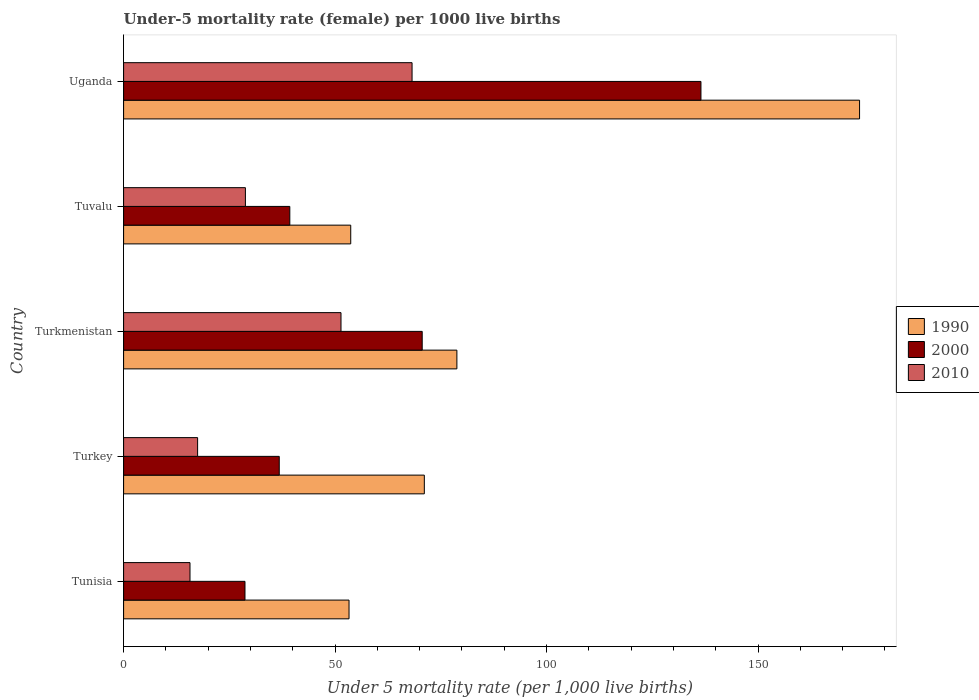How many groups of bars are there?
Ensure brevity in your answer.  5. What is the label of the 1st group of bars from the top?
Provide a succinct answer. Uganda. In how many cases, is the number of bars for a given country not equal to the number of legend labels?
Ensure brevity in your answer.  0. What is the under-five mortality rate in 2000 in Turkey?
Give a very brief answer. 36.8. Across all countries, what is the maximum under-five mortality rate in 2010?
Give a very brief answer. 68.2. Across all countries, what is the minimum under-five mortality rate in 2000?
Ensure brevity in your answer.  28.7. In which country was the under-five mortality rate in 1990 maximum?
Your answer should be very brief. Uganda. In which country was the under-five mortality rate in 2000 minimum?
Keep it short and to the point. Tunisia. What is the total under-five mortality rate in 1990 in the graph?
Provide a short and direct response. 430.9. What is the difference between the under-five mortality rate in 2010 in Tunisia and that in Turkmenistan?
Give a very brief answer. -35.7. What is the difference between the under-five mortality rate in 2010 in Uganda and the under-five mortality rate in 1990 in Tunisia?
Keep it short and to the point. 14.9. What is the average under-five mortality rate in 2010 per country?
Keep it short and to the point. 36.32. What is the difference between the under-five mortality rate in 2010 and under-five mortality rate in 1990 in Turkmenistan?
Offer a terse response. -27.4. What is the ratio of the under-five mortality rate in 2000 in Tunisia to that in Turkmenistan?
Your answer should be compact. 0.41. Is the difference between the under-five mortality rate in 2010 in Turkmenistan and Uganda greater than the difference between the under-five mortality rate in 1990 in Turkmenistan and Uganda?
Offer a very short reply. Yes. What is the difference between the highest and the second highest under-five mortality rate in 2000?
Give a very brief answer. 65.9. What is the difference between the highest and the lowest under-five mortality rate in 2010?
Make the answer very short. 52.5. In how many countries, is the under-five mortality rate in 1990 greater than the average under-five mortality rate in 1990 taken over all countries?
Your response must be concise. 1. What does the 1st bar from the top in Turkey represents?
Keep it short and to the point. 2010. Is it the case that in every country, the sum of the under-five mortality rate in 2010 and under-five mortality rate in 1990 is greater than the under-five mortality rate in 2000?
Your answer should be very brief. Yes. Are all the bars in the graph horizontal?
Provide a short and direct response. Yes. How many countries are there in the graph?
Your answer should be compact. 5. What is the difference between two consecutive major ticks on the X-axis?
Offer a very short reply. 50. Does the graph contain any zero values?
Your answer should be very brief. No. Where does the legend appear in the graph?
Your response must be concise. Center right. How many legend labels are there?
Ensure brevity in your answer.  3. What is the title of the graph?
Your answer should be compact. Under-5 mortality rate (female) per 1000 live births. Does "2002" appear as one of the legend labels in the graph?
Make the answer very short. No. What is the label or title of the X-axis?
Provide a succinct answer. Under 5 mortality rate (per 1,0 live births). What is the label or title of the Y-axis?
Provide a succinct answer. Country. What is the Under 5 mortality rate (per 1,000 live births) in 1990 in Tunisia?
Your answer should be compact. 53.3. What is the Under 5 mortality rate (per 1,000 live births) of 2000 in Tunisia?
Provide a short and direct response. 28.7. What is the Under 5 mortality rate (per 1,000 live births) in 2010 in Tunisia?
Your answer should be compact. 15.7. What is the Under 5 mortality rate (per 1,000 live births) in 1990 in Turkey?
Provide a short and direct response. 71.1. What is the Under 5 mortality rate (per 1,000 live births) of 2000 in Turkey?
Your answer should be very brief. 36.8. What is the Under 5 mortality rate (per 1,000 live births) of 1990 in Turkmenistan?
Offer a terse response. 78.8. What is the Under 5 mortality rate (per 1,000 live births) of 2000 in Turkmenistan?
Your answer should be very brief. 70.6. What is the Under 5 mortality rate (per 1,000 live births) in 2010 in Turkmenistan?
Offer a terse response. 51.4. What is the Under 5 mortality rate (per 1,000 live births) in 1990 in Tuvalu?
Ensure brevity in your answer.  53.7. What is the Under 5 mortality rate (per 1,000 live births) of 2000 in Tuvalu?
Offer a terse response. 39.3. What is the Under 5 mortality rate (per 1,000 live births) in 2010 in Tuvalu?
Offer a terse response. 28.8. What is the Under 5 mortality rate (per 1,000 live births) in 1990 in Uganda?
Make the answer very short. 174. What is the Under 5 mortality rate (per 1,000 live births) in 2000 in Uganda?
Your answer should be compact. 136.5. What is the Under 5 mortality rate (per 1,000 live births) of 2010 in Uganda?
Your response must be concise. 68.2. Across all countries, what is the maximum Under 5 mortality rate (per 1,000 live births) of 1990?
Make the answer very short. 174. Across all countries, what is the maximum Under 5 mortality rate (per 1,000 live births) of 2000?
Give a very brief answer. 136.5. Across all countries, what is the maximum Under 5 mortality rate (per 1,000 live births) in 2010?
Your response must be concise. 68.2. Across all countries, what is the minimum Under 5 mortality rate (per 1,000 live births) in 1990?
Keep it short and to the point. 53.3. Across all countries, what is the minimum Under 5 mortality rate (per 1,000 live births) of 2000?
Your response must be concise. 28.7. Across all countries, what is the minimum Under 5 mortality rate (per 1,000 live births) in 2010?
Your answer should be compact. 15.7. What is the total Under 5 mortality rate (per 1,000 live births) of 1990 in the graph?
Offer a very short reply. 430.9. What is the total Under 5 mortality rate (per 1,000 live births) in 2000 in the graph?
Give a very brief answer. 311.9. What is the total Under 5 mortality rate (per 1,000 live births) in 2010 in the graph?
Keep it short and to the point. 181.6. What is the difference between the Under 5 mortality rate (per 1,000 live births) in 1990 in Tunisia and that in Turkey?
Offer a terse response. -17.8. What is the difference between the Under 5 mortality rate (per 1,000 live births) of 2000 in Tunisia and that in Turkey?
Provide a short and direct response. -8.1. What is the difference between the Under 5 mortality rate (per 1,000 live births) of 1990 in Tunisia and that in Turkmenistan?
Provide a succinct answer. -25.5. What is the difference between the Under 5 mortality rate (per 1,000 live births) in 2000 in Tunisia and that in Turkmenistan?
Keep it short and to the point. -41.9. What is the difference between the Under 5 mortality rate (per 1,000 live births) in 2010 in Tunisia and that in Turkmenistan?
Offer a terse response. -35.7. What is the difference between the Under 5 mortality rate (per 1,000 live births) in 2000 in Tunisia and that in Tuvalu?
Your answer should be very brief. -10.6. What is the difference between the Under 5 mortality rate (per 1,000 live births) in 2010 in Tunisia and that in Tuvalu?
Your answer should be compact. -13.1. What is the difference between the Under 5 mortality rate (per 1,000 live births) in 1990 in Tunisia and that in Uganda?
Offer a terse response. -120.7. What is the difference between the Under 5 mortality rate (per 1,000 live births) in 2000 in Tunisia and that in Uganda?
Give a very brief answer. -107.8. What is the difference between the Under 5 mortality rate (per 1,000 live births) in 2010 in Tunisia and that in Uganda?
Provide a succinct answer. -52.5. What is the difference between the Under 5 mortality rate (per 1,000 live births) of 1990 in Turkey and that in Turkmenistan?
Offer a very short reply. -7.7. What is the difference between the Under 5 mortality rate (per 1,000 live births) in 2000 in Turkey and that in Turkmenistan?
Your answer should be very brief. -33.8. What is the difference between the Under 5 mortality rate (per 1,000 live births) in 2010 in Turkey and that in Turkmenistan?
Provide a short and direct response. -33.9. What is the difference between the Under 5 mortality rate (per 1,000 live births) of 1990 in Turkey and that in Tuvalu?
Offer a terse response. 17.4. What is the difference between the Under 5 mortality rate (per 1,000 live births) of 1990 in Turkey and that in Uganda?
Offer a very short reply. -102.9. What is the difference between the Under 5 mortality rate (per 1,000 live births) in 2000 in Turkey and that in Uganda?
Offer a very short reply. -99.7. What is the difference between the Under 5 mortality rate (per 1,000 live births) of 2010 in Turkey and that in Uganda?
Your response must be concise. -50.7. What is the difference between the Under 5 mortality rate (per 1,000 live births) of 1990 in Turkmenistan and that in Tuvalu?
Your answer should be compact. 25.1. What is the difference between the Under 5 mortality rate (per 1,000 live births) of 2000 in Turkmenistan and that in Tuvalu?
Offer a terse response. 31.3. What is the difference between the Under 5 mortality rate (per 1,000 live births) in 2010 in Turkmenistan and that in Tuvalu?
Ensure brevity in your answer.  22.6. What is the difference between the Under 5 mortality rate (per 1,000 live births) of 1990 in Turkmenistan and that in Uganda?
Your answer should be very brief. -95.2. What is the difference between the Under 5 mortality rate (per 1,000 live births) of 2000 in Turkmenistan and that in Uganda?
Offer a very short reply. -65.9. What is the difference between the Under 5 mortality rate (per 1,000 live births) of 2010 in Turkmenistan and that in Uganda?
Offer a very short reply. -16.8. What is the difference between the Under 5 mortality rate (per 1,000 live births) of 1990 in Tuvalu and that in Uganda?
Your response must be concise. -120.3. What is the difference between the Under 5 mortality rate (per 1,000 live births) of 2000 in Tuvalu and that in Uganda?
Your response must be concise. -97.2. What is the difference between the Under 5 mortality rate (per 1,000 live births) of 2010 in Tuvalu and that in Uganda?
Make the answer very short. -39.4. What is the difference between the Under 5 mortality rate (per 1,000 live births) of 1990 in Tunisia and the Under 5 mortality rate (per 1,000 live births) of 2010 in Turkey?
Offer a terse response. 35.8. What is the difference between the Under 5 mortality rate (per 1,000 live births) in 2000 in Tunisia and the Under 5 mortality rate (per 1,000 live births) in 2010 in Turkey?
Make the answer very short. 11.2. What is the difference between the Under 5 mortality rate (per 1,000 live births) in 1990 in Tunisia and the Under 5 mortality rate (per 1,000 live births) in 2000 in Turkmenistan?
Your answer should be compact. -17.3. What is the difference between the Under 5 mortality rate (per 1,000 live births) of 2000 in Tunisia and the Under 5 mortality rate (per 1,000 live births) of 2010 in Turkmenistan?
Provide a short and direct response. -22.7. What is the difference between the Under 5 mortality rate (per 1,000 live births) of 1990 in Tunisia and the Under 5 mortality rate (per 1,000 live births) of 2000 in Tuvalu?
Offer a very short reply. 14. What is the difference between the Under 5 mortality rate (per 1,000 live births) in 2000 in Tunisia and the Under 5 mortality rate (per 1,000 live births) in 2010 in Tuvalu?
Your response must be concise. -0.1. What is the difference between the Under 5 mortality rate (per 1,000 live births) of 1990 in Tunisia and the Under 5 mortality rate (per 1,000 live births) of 2000 in Uganda?
Your answer should be compact. -83.2. What is the difference between the Under 5 mortality rate (per 1,000 live births) of 1990 in Tunisia and the Under 5 mortality rate (per 1,000 live births) of 2010 in Uganda?
Your answer should be very brief. -14.9. What is the difference between the Under 5 mortality rate (per 1,000 live births) of 2000 in Tunisia and the Under 5 mortality rate (per 1,000 live births) of 2010 in Uganda?
Your answer should be compact. -39.5. What is the difference between the Under 5 mortality rate (per 1,000 live births) of 1990 in Turkey and the Under 5 mortality rate (per 1,000 live births) of 2000 in Turkmenistan?
Your answer should be very brief. 0.5. What is the difference between the Under 5 mortality rate (per 1,000 live births) in 1990 in Turkey and the Under 5 mortality rate (per 1,000 live births) in 2010 in Turkmenistan?
Provide a succinct answer. 19.7. What is the difference between the Under 5 mortality rate (per 1,000 live births) of 2000 in Turkey and the Under 5 mortality rate (per 1,000 live births) of 2010 in Turkmenistan?
Offer a very short reply. -14.6. What is the difference between the Under 5 mortality rate (per 1,000 live births) of 1990 in Turkey and the Under 5 mortality rate (per 1,000 live births) of 2000 in Tuvalu?
Your answer should be compact. 31.8. What is the difference between the Under 5 mortality rate (per 1,000 live births) in 1990 in Turkey and the Under 5 mortality rate (per 1,000 live births) in 2010 in Tuvalu?
Offer a terse response. 42.3. What is the difference between the Under 5 mortality rate (per 1,000 live births) in 2000 in Turkey and the Under 5 mortality rate (per 1,000 live births) in 2010 in Tuvalu?
Your response must be concise. 8. What is the difference between the Under 5 mortality rate (per 1,000 live births) of 1990 in Turkey and the Under 5 mortality rate (per 1,000 live births) of 2000 in Uganda?
Make the answer very short. -65.4. What is the difference between the Under 5 mortality rate (per 1,000 live births) of 1990 in Turkey and the Under 5 mortality rate (per 1,000 live births) of 2010 in Uganda?
Your answer should be compact. 2.9. What is the difference between the Under 5 mortality rate (per 1,000 live births) of 2000 in Turkey and the Under 5 mortality rate (per 1,000 live births) of 2010 in Uganda?
Your answer should be compact. -31.4. What is the difference between the Under 5 mortality rate (per 1,000 live births) of 1990 in Turkmenistan and the Under 5 mortality rate (per 1,000 live births) of 2000 in Tuvalu?
Provide a short and direct response. 39.5. What is the difference between the Under 5 mortality rate (per 1,000 live births) in 1990 in Turkmenistan and the Under 5 mortality rate (per 1,000 live births) in 2010 in Tuvalu?
Provide a succinct answer. 50. What is the difference between the Under 5 mortality rate (per 1,000 live births) of 2000 in Turkmenistan and the Under 5 mortality rate (per 1,000 live births) of 2010 in Tuvalu?
Make the answer very short. 41.8. What is the difference between the Under 5 mortality rate (per 1,000 live births) in 1990 in Turkmenistan and the Under 5 mortality rate (per 1,000 live births) in 2000 in Uganda?
Offer a very short reply. -57.7. What is the difference between the Under 5 mortality rate (per 1,000 live births) of 1990 in Turkmenistan and the Under 5 mortality rate (per 1,000 live births) of 2010 in Uganda?
Give a very brief answer. 10.6. What is the difference between the Under 5 mortality rate (per 1,000 live births) of 2000 in Turkmenistan and the Under 5 mortality rate (per 1,000 live births) of 2010 in Uganda?
Provide a succinct answer. 2.4. What is the difference between the Under 5 mortality rate (per 1,000 live births) of 1990 in Tuvalu and the Under 5 mortality rate (per 1,000 live births) of 2000 in Uganda?
Keep it short and to the point. -82.8. What is the difference between the Under 5 mortality rate (per 1,000 live births) in 2000 in Tuvalu and the Under 5 mortality rate (per 1,000 live births) in 2010 in Uganda?
Your answer should be compact. -28.9. What is the average Under 5 mortality rate (per 1,000 live births) of 1990 per country?
Ensure brevity in your answer.  86.18. What is the average Under 5 mortality rate (per 1,000 live births) in 2000 per country?
Your response must be concise. 62.38. What is the average Under 5 mortality rate (per 1,000 live births) of 2010 per country?
Provide a succinct answer. 36.32. What is the difference between the Under 5 mortality rate (per 1,000 live births) in 1990 and Under 5 mortality rate (per 1,000 live births) in 2000 in Tunisia?
Make the answer very short. 24.6. What is the difference between the Under 5 mortality rate (per 1,000 live births) of 1990 and Under 5 mortality rate (per 1,000 live births) of 2010 in Tunisia?
Ensure brevity in your answer.  37.6. What is the difference between the Under 5 mortality rate (per 1,000 live births) in 2000 and Under 5 mortality rate (per 1,000 live births) in 2010 in Tunisia?
Your response must be concise. 13. What is the difference between the Under 5 mortality rate (per 1,000 live births) of 1990 and Under 5 mortality rate (per 1,000 live births) of 2000 in Turkey?
Keep it short and to the point. 34.3. What is the difference between the Under 5 mortality rate (per 1,000 live births) of 1990 and Under 5 mortality rate (per 1,000 live births) of 2010 in Turkey?
Keep it short and to the point. 53.6. What is the difference between the Under 5 mortality rate (per 1,000 live births) in 2000 and Under 5 mortality rate (per 1,000 live births) in 2010 in Turkey?
Make the answer very short. 19.3. What is the difference between the Under 5 mortality rate (per 1,000 live births) in 1990 and Under 5 mortality rate (per 1,000 live births) in 2000 in Turkmenistan?
Provide a succinct answer. 8.2. What is the difference between the Under 5 mortality rate (per 1,000 live births) of 1990 and Under 5 mortality rate (per 1,000 live births) of 2010 in Turkmenistan?
Provide a succinct answer. 27.4. What is the difference between the Under 5 mortality rate (per 1,000 live births) of 1990 and Under 5 mortality rate (per 1,000 live births) of 2010 in Tuvalu?
Provide a succinct answer. 24.9. What is the difference between the Under 5 mortality rate (per 1,000 live births) in 1990 and Under 5 mortality rate (per 1,000 live births) in 2000 in Uganda?
Your response must be concise. 37.5. What is the difference between the Under 5 mortality rate (per 1,000 live births) in 1990 and Under 5 mortality rate (per 1,000 live births) in 2010 in Uganda?
Provide a succinct answer. 105.8. What is the difference between the Under 5 mortality rate (per 1,000 live births) of 2000 and Under 5 mortality rate (per 1,000 live births) of 2010 in Uganda?
Offer a very short reply. 68.3. What is the ratio of the Under 5 mortality rate (per 1,000 live births) of 1990 in Tunisia to that in Turkey?
Keep it short and to the point. 0.75. What is the ratio of the Under 5 mortality rate (per 1,000 live births) of 2000 in Tunisia to that in Turkey?
Offer a very short reply. 0.78. What is the ratio of the Under 5 mortality rate (per 1,000 live births) of 2010 in Tunisia to that in Turkey?
Provide a succinct answer. 0.9. What is the ratio of the Under 5 mortality rate (per 1,000 live births) of 1990 in Tunisia to that in Turkmenistan?
Your response must be concise. 0.68. What is the ratio of the Under 5 mortality rate (per 1,000 live births) in 2000 in Tunisia to that in Turkmenistan?
Your response must be concise. 0.41. What is the ratio of the Under 5 mortality rate (per 1,000 live births) in 2010 in Tunisia to that in Turkmenistan?
Ensure brevity in your answer.  0.31. What is the ratio of the Under 5 mortality rate (per 1,000 live births) in 2000 in Tunisia to that in Tuvalu?
Provide a short and direct response. 0.73. What is the ratio of the Under 5 mortality rate (per 1,000 live births) in 2010 in Tunisia to that in Tuvalu?
Offer a terse response. 0.55. What is the ratio of the Under 5 mortality rate (per 1,000 live births) in 1990 in Tunisia to that in Uganda?
Keep it short and to the point. 0.31. What is the ratio of the Under 5 mortality rate (per 1,000 live births) of 2000 in Tunisia to that in Uganda?
Provide a succinct answer. 0.21. What is the ratio of the Under 5 mortality rate (per 1,000 live births) of 2010 in Tunisia to that in Uganda?
Ensure brevity in your answer.  0.23. What is the ratio of the Under 5 mortality rate (per 1,000 live births) of 1990 in Turkey to that in Turkmenistan?
Provide a short and direct response. 0.9. What is the ratio of the Under 5 mortality rate (per 1,000 live births) of 2000 in Turkey to that in Turkmenistan?
Ensure brevity in your answer.  0.52. What is the ratio of the Under 5 mortality rate (per 1,000 live births) of 2010 in Turkey to that in Turkmenistan?
Your response must be concise. 0.34. What is the ratio of the Under 5 mortality rate (per 1,000 live births) of 1990 in Turkey to that in Tuvalu?
Your answer should be compact. 1.32. What is the ratio of the Under 5 mortality rate (per 1,000 live births) in 2000 in Turkey to that in Tuvalu?
Offer a terse response. 0.94. What is the ratio of the Under 5 mortality rate (per 1,000 live births) in 2010 in Turkey to that in Tuvalu?
Your response must be concise. 0.61. What is the ratio of the Under 5 mortality rate (per 1,000 live births) in 1990 in Turkey to that in Uganda?
Provide a short and direct response. 0.41. What is the ratio of the Under 5 mortality rate (per 1,000 live births) in 2000 in Turkey to that in Uganda?
Make the answer very short. 0.27. What is the ratio of the Under 5 mortality rate (per 1,000 live births) in 2010 in Turkey to that in Uganda?
Keep it short and to the point. 0.26. What is the ratio of the Under 5 mortality rate (per 1,000 live births) of 1990 in Turkmenistan to that in Tuvalu?
Make the answer very short. 1.47. What is the ratio of the Under 5 mortality rate (per 1,000 live births) of 2000 in Turkmenistan to that in Tuvalu?
Ensure brevity in your answer.  1.8. What is the ratio of the Under 5 mortality rate (per 1,000 live births) in 2010 in Turkmenistan to that in Tuvalu?
Your answer should be compact. 1.78. What is the ratio of the Under 5 mortality rate (per 1,000 live births) in 1990 in Turkmenistan to that in Uganda?
Make the answer very short. 0.45. What is the ratio of the Under 5 mortality rate (per 1,000 live births) in 2000 in Turkmenistan to that in Uganda?
Provide a short and direct response. 0.52. What is the ratio of the Under 5 mortality rate (per 1,000 live births) of 2010 in Turkmenistan to that in Uganda?
Keep it short and to the point. 0.75. What is the ratio of the Under 5 mortality rate (per 1,000 live births) of 1990 in Tuvalu to that in Uganda?
Your answer should be compact. 0.31. What is the ratio of the Under 5 mortality rate (per 1,000 live births) of 2000 in Tuvalu to that in Uganda?
Provide a short and direct response. 0.29. What is the ratio of the Under 5 mortality rate (per 1,000 live births) of 2010 in Tuvalu to that in Uganda?
Keep it short and to the point. 0.42. What is the difference between the highest and the second highest Under 5 mortality rate (per 1,000 live births) in 1990?
Give a very brief answer. 95.2. What is the difference between the highest and the second highest Under 5 mortality rate (per 1,000 live births) in 2000?
Keep it short and to the point. 65.9. What is the difference between the highest and the lowest Under 5 mortality rate (per 1,000 live births) of 1990?
Your response must be concise. 120.7. What is the difference between the highest and the lowest Under 5 mortality rate (per 1,000 live births) in 2000?
Provide a short and direct response. 107.8. What is the difference between the highest and the lowest Under 5 mortality rate (per 1,000 live births) in 2010?
Your answer should be compact. 52.5. 